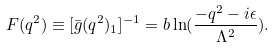Convert formula to latex. <formula><loc_0><loc_0><loc_500><loc_500>F ( q ^ { 2 } ) \equiv [ \bar { g } ( q ^ { 2 } ) _ { 1 } ] ^ { - 1 } = b \ln ( \frac { - q ^ { 2 } - i \epsilon } { \Lambda ^ { 2 } } ) .</formula> 